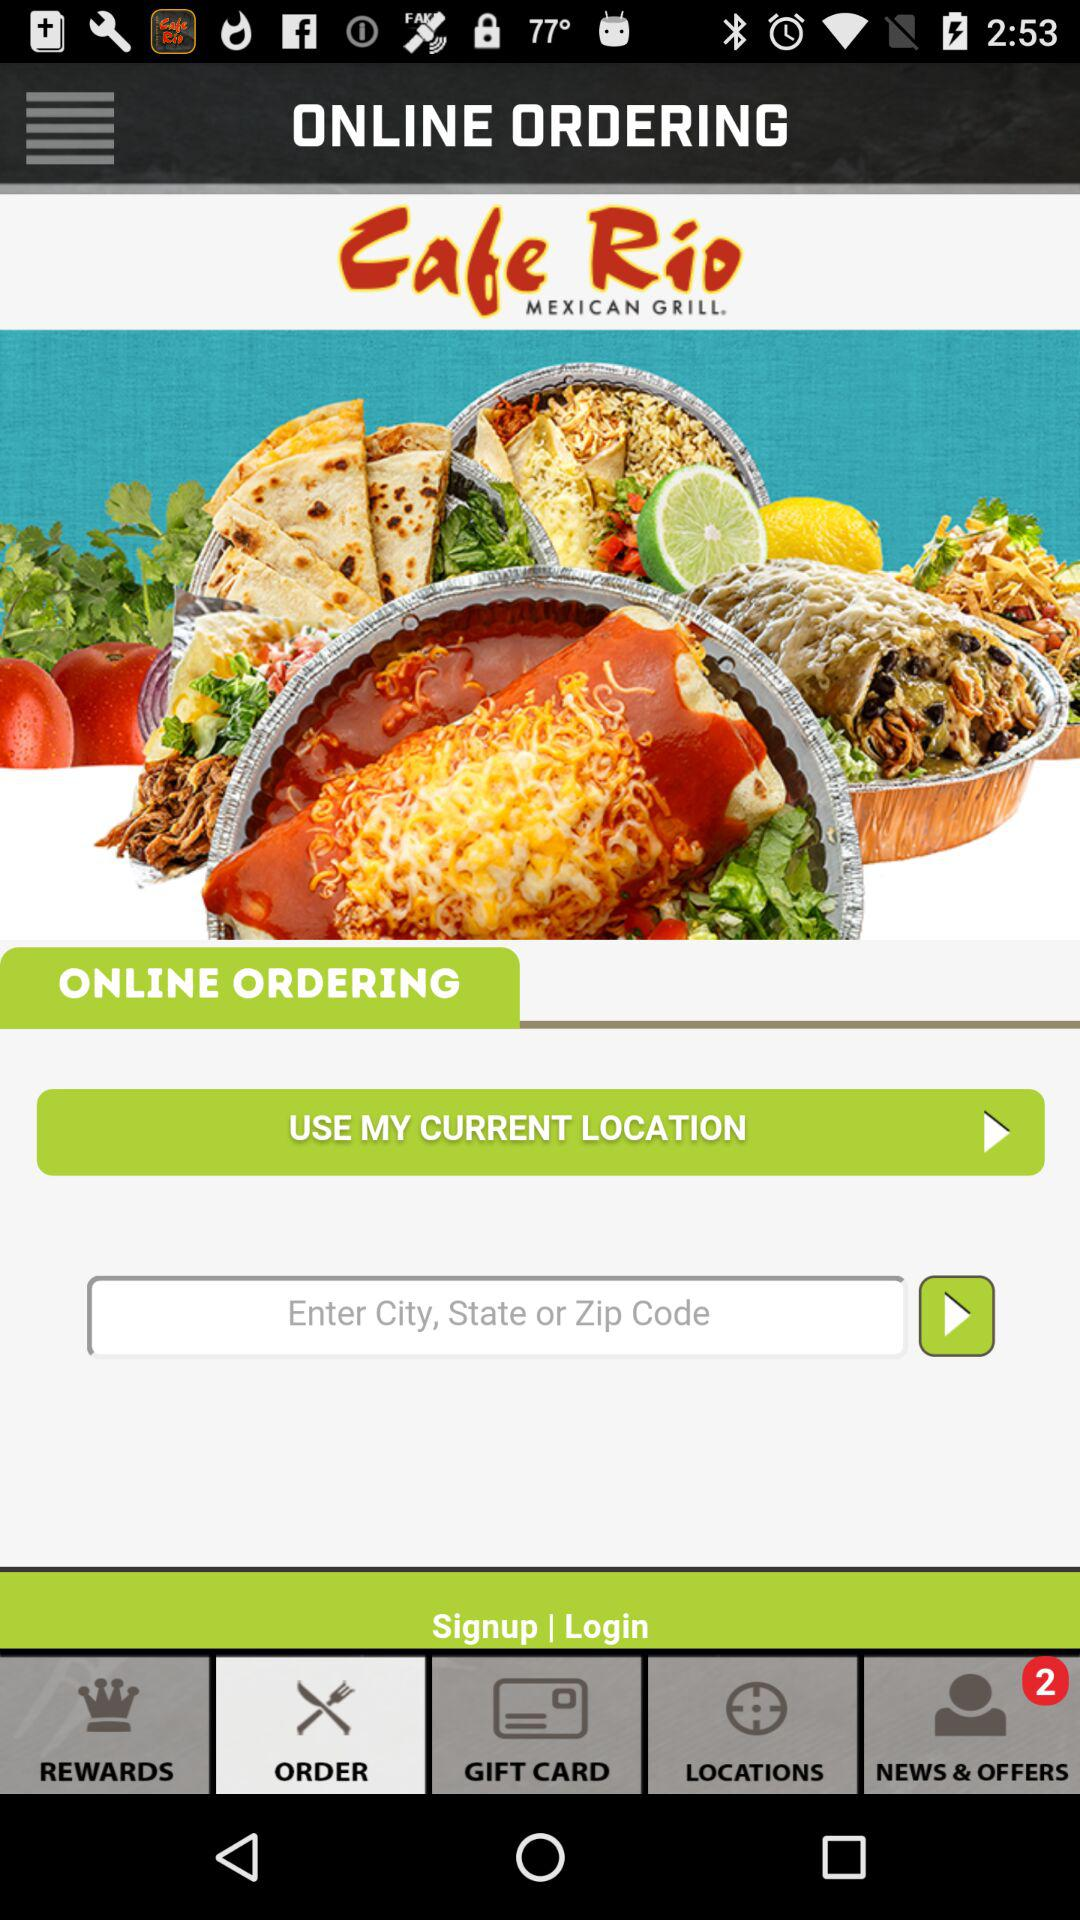Which tab is currently active at the bottom bar? The currently active tab at the bottom bar is "ORDER". 